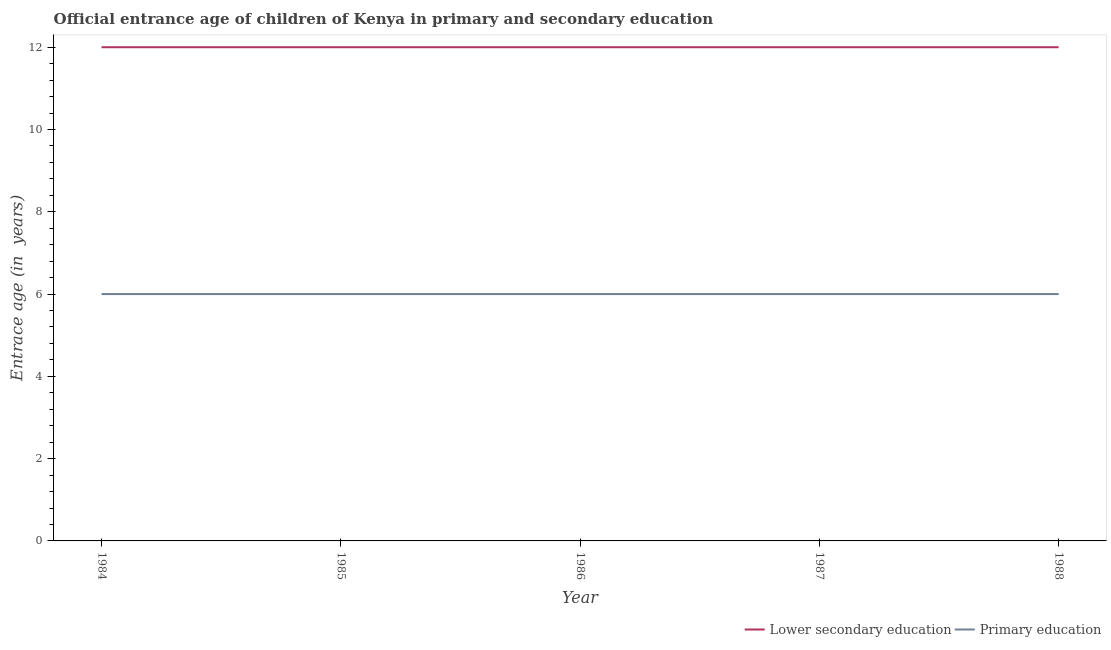Does the line corresponding to entrance age of chiildren in primary education intersect with the line corresponding to entrance age of children in lower secondary education?
Your answer should be compact. No. What is the entrance age of chiildren in primary education in 1988?
Offer a very short reply. 6. Across all years, what is the maximum entrance age of children in lower secondary education?
Offer a terse response. 12. Across all years, what is the minimum entrance age of children in lower secondary education?
Ensure brevity in your answer.  12. What is the total entrance age of chiildren in primary education in the graph?
Give a very brief answer. 30. What is the difference between the entrance age of chiildren in primary education in 1984 and that in 1986?
Your answer should be compact. 0. What is the difference between the entrance age of children in lower secondary education in 1988 and the entrance age of chiildren in primary education in 1985?
Give a very brief answer. 6. In the year 1987, what is the difference between the entrance age of children in lower secondary education and entrance age of chiildren in primary education?
Provide a succinct answer. 6. In how many years, is the entrance age of children in lower secondary education greater than 0.4 years?
Your answer should be compact. 5. Is the entrance age of chiildren in primary education in 1984 less than that in 1985?
Give a very brief answer. No. Is the difference between the entrance age of children in lower secondary education in 1984 and 1985 greater than the difference between the entrance age of chiildren in primary education in 1984 and 1985?
Give a very brief answer. No. What is the difference between the highest and the lowest entrance age of chiildren in primary education?
Your answer should be compact. 0. Is the entrance age of chiildren in primary education strictly greater than the entrance age of children in lower secondary education over the years?
Your response must be concise. No. How many lines are there?
Ensure brevity in your answer.  2. Are the values on the major ticks of Y-axis written in scientific E-notation?
Your answer should be very brief. No. Where does the legend appear in the graph?
Keep it short and to the point. Bottom right. How many legend labels are there?
Offer a terse response. 2. How are the legend labels stacked?
Keep it short and to the point. Horizontal. What is the title of the graph?
Your answer should be compact. Official entrance age of children of Kenya in primary and secondary education. Does "IMF nonconcessional" appear as one of the legend labels in the graph?
Provide a short and direct response. No. What is the label or title of the Y-axis?
Keep it short and to the point. Entrace age (in  years). What is the Entrace age (in  years) of Lower secondary education in 1985?
Give a very brief answer. 12. What is the Entrace age (in  years) in Lower secondary education in 1986?
Provide a succinct answer. 12. What is the Entrace age (in  years) of Primary education in 1987?
Your answer should be very brief. 6. What is the Entrace age (in  years) in Lower secondary education in 1988?
Make the answer very short. 12. What is the Entrace age (in  years) in Primary education in 1988?
Provide a succinct answer. 6. What is the difference between the Entrace age (in  years) of Primary education in 1984 and that in 1985?
Your answer should be compact. 0. What is the difference between the Entrace age (in  years) of Lower secondary education in 1984 and that in 1986?
Your answer should be compact. 0. What is the difference between the Entrace age (in  years) of Lower secondary education in 1984 and that in 1987?
Make the answer very short. 0. What is the difference between the Entrace age (in  years) of Primary education in 1984 and that in 1987?
Your answer should be very brief. 0. What is the difference between the Entrace age (in  years) of Lower secondary education in 1984 and that in 1988?
Offer a terse response. 0. What is the difference between the Entrace age (in  years) of Primary education in 1984 and that in 1988?
Your answer should be compact. 0. What is the difference between the Entrace age (in  years) of Primary education in 1985 and that in 1986?
Offer a terse response. 0. What is the difference between the Entrace age (in  years) in Lower secondary education in 1985 and that in 1987?
Your response must be concise. 0. What is the difference between the Entrace age (in  years) in Lower secondary education in 1985 and that in 1988?
Offer a terse response. 0. What is the difference between the Entrace age (in  years) of Primary education in 1985 and that in 1988?
Provide a succinct answer. 0. What is the difference between the Entrace age (in  years) of Lower secondary education in 1986 and that in 1988?
Your response must be concise. 0. What is the difference between the Entrace age (in  years) in Primary education in 1987 and that in 1988?
Make the answer very short. 0. What is the difference between the Entrace age (in  years) of Lower secondary education in 1984 and the Entrace age (in  years) of Primary education in 1985?
Your answer should be very brief. 6. What is the difference between the Entrace age (in  years) in Lower secondary education in 1984 and the Entrace age (in  years) in Primary education in 1987?
Provide a succinct answer. 6. What is the difference between the Entrace age (in  years) in Lower secondary education in 1985 and the Entrace age (in  years) in Primary education in 1986?
Offer a very short reply. 6. What is the difference between the Entrace age (in  years) in Lower secondary education in 1986 and the Entrace age (in  years) in Primary education in 1987?
Provide a short and direct response. 6. In the year 1984, what is the difference between the Entrace age (in  years) in Lower secondary education and Entrace age (in  years) in Primary education?
Your response must be concise. 6. In the year 1987, what is the difference between the Entrace age (in  years) of Lower secondary education and Entrace age (in  years) of Primary education?
Make the answer very short. 6. What is the ratio of the Entrace age (in  years) of Primary education in 1984 to that in 1985?
Your response must be concise. 1. What is the ratio of the Entrace age (in  years) of Lower secondary education in 1984 to that in 1987?
Ensure brevity in your answer.  1. What is the ratio of the Entrace age (in  years) in Primary education in 1984 to that in 1987?
Provide a succinct answer. 1. What is the ratio of the Entrace age (in  years) of Lower secondary education in 1984 to that in 1988?
Give a very brief answer. 1. What is the ratio of the Entrace age (in  years) in Primary education in 1984 to that in 1988?
Your answer should be compact. 1. What is the ratio of the Entrace age (in  years) in Lower secondary education in 1985 to that in 1986?
Offer a terse response. 1. What is the ratio of the Entrace age (in  years) of Primary education in 1985 to that in 1986?
Provide a succinct answer. 1. What is the ratio of the Entrace age (in  years) of Lower secondary education in 1985 to that in 1988?
Give a very brief answer. 1. What is the ratio of the Entrace age (in  years) in Primary education in 1985 to that in 1988?
Your response must be concise. 1. What is the ratio of the Entrace age (in  years) of Primary education in 1986 to that in 1987?
Your answer should be compact. 1. What is the ratio of the Entrace age (in  years) of Primary education in 1986 to that in 1988?
Your response must be concise. 1. What is the ratio of the Entrace age (in  years) of Primary education in 1987 to that in 1988?
Keep it short and to the point. 1. What is the difference between the highest and the second highest Entrace age (in  years) of Primary education?
Offer a very short reply. 0. What is the difference between the highest and the lowest Entrace age (in  years) of Primary education?
Your answer should be very brief. 0. 